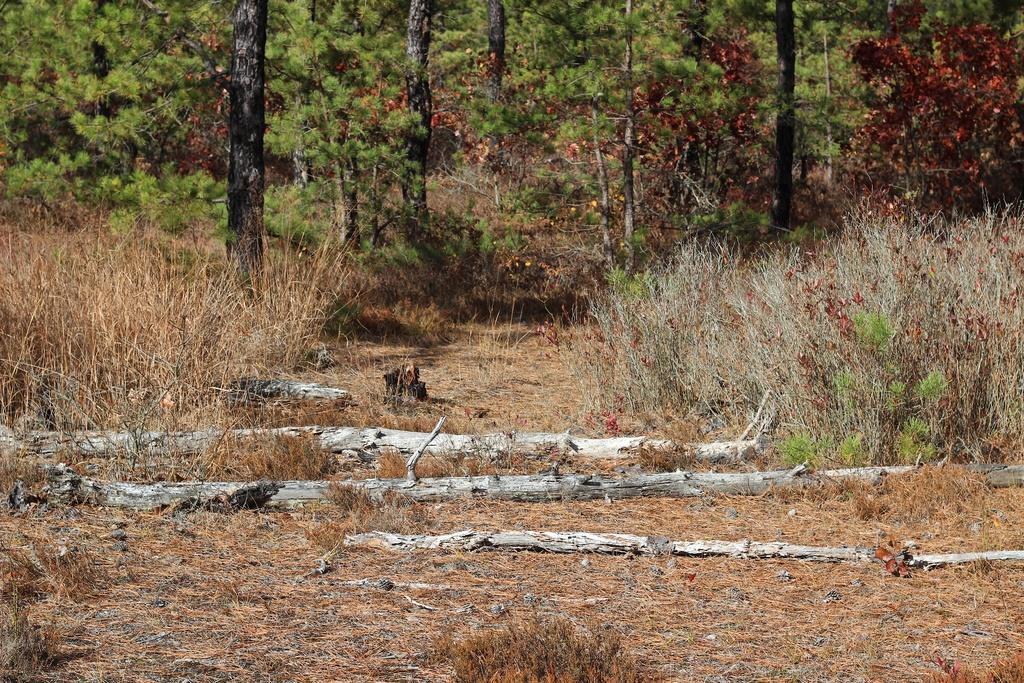Can you describe this image briefly? In this picture i can see the trees, plants and grass. At the bottom i can see the trees which are fell down on the ground. 